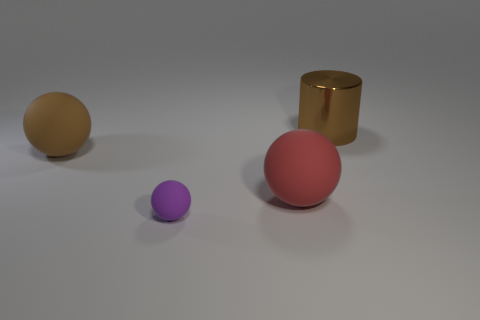What size is the matte ball that is the same color as the big shiny object?
Offer a terse response. Large. There is a matte object that is the same color as the cylinder; what shape is it?
Your answer should be compact. Sphere. There is a big rubber object to the right of the large brown matte sphere; what shape is it?
Your response must be concise. Sphere. Does the large brown thing left of the tiny purple rubber object have the same shape as the purple thing?
Your response must be concise. Yes. What number of objects are matte objects on the right side of the purple matte sphere or large brown objects?
Give a very brief answer. 3. There is a small thing that is the same shape as the big brown matte object; what color is it?
Your answer should be very brief. Purple. Is there any other thing that has the same color as the big shiny cylinder?
Provide a succinct answer. Yes. There is a brown object behind the big brown sphere; how big is it?
Your answer should be compact. Large. There is a big metal object; does it have the same color as the matte object that is in front of the large red object?
Give a very brief answer. No. What number of other things are the same material as the brown cylinder?
Make the answer very short. 0. 